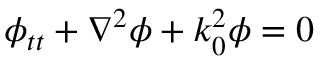<formula> <loc_0><loc_0><loc_500><loc_500>\phi _ { t t } + \nabla ^ { 2 } \phi + k _ { 0 } ^ { 2 } \phi = 0</formula> 